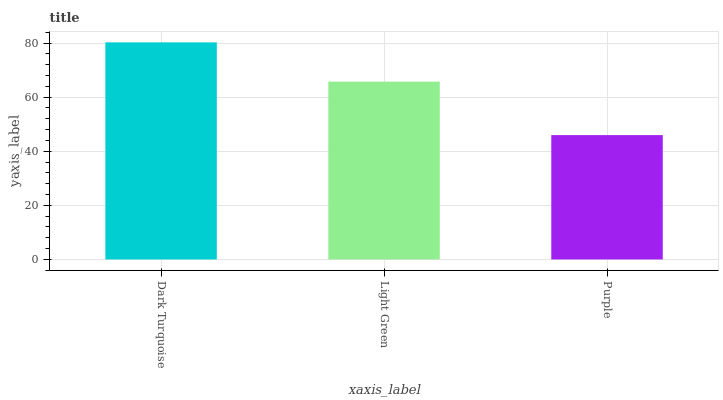Is Light Green the minimum?
Answer yes or no. No. Is Light Green the maximum?
Answer yes or no. No. Is Dark Turquoise greater than Light Green?
Answer yes or no. Yes. Is Light Green less than Dark Turquoise?
Answer yes or no. Yes. Is Light Green greater than Dark Turquoise?
Answer yes or no. No. Is Dark Turquoise less than Light Green?
Answer yes or no. No. Is Light Green the high median?
Answer yes or no. Yes. Is Light Green the low median?
Answer yes or no. Yes. Is Purple the high median?
Answer yes or no. No. Is Dark Turquoise the low median?
Answer yes or no. No. 